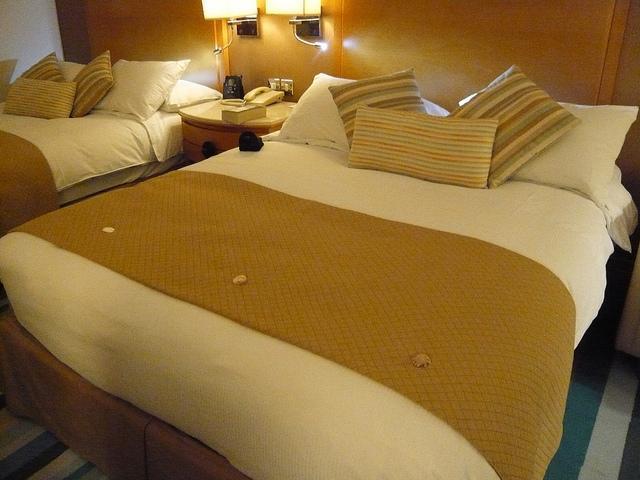How many pillows are visible?
Give a very brief answer. 11. How many beds are in the photo?
Give a very brief answer. 2. How many people are at the base of the stairs to the right of the boat?
Give a very brief answer. 0. 